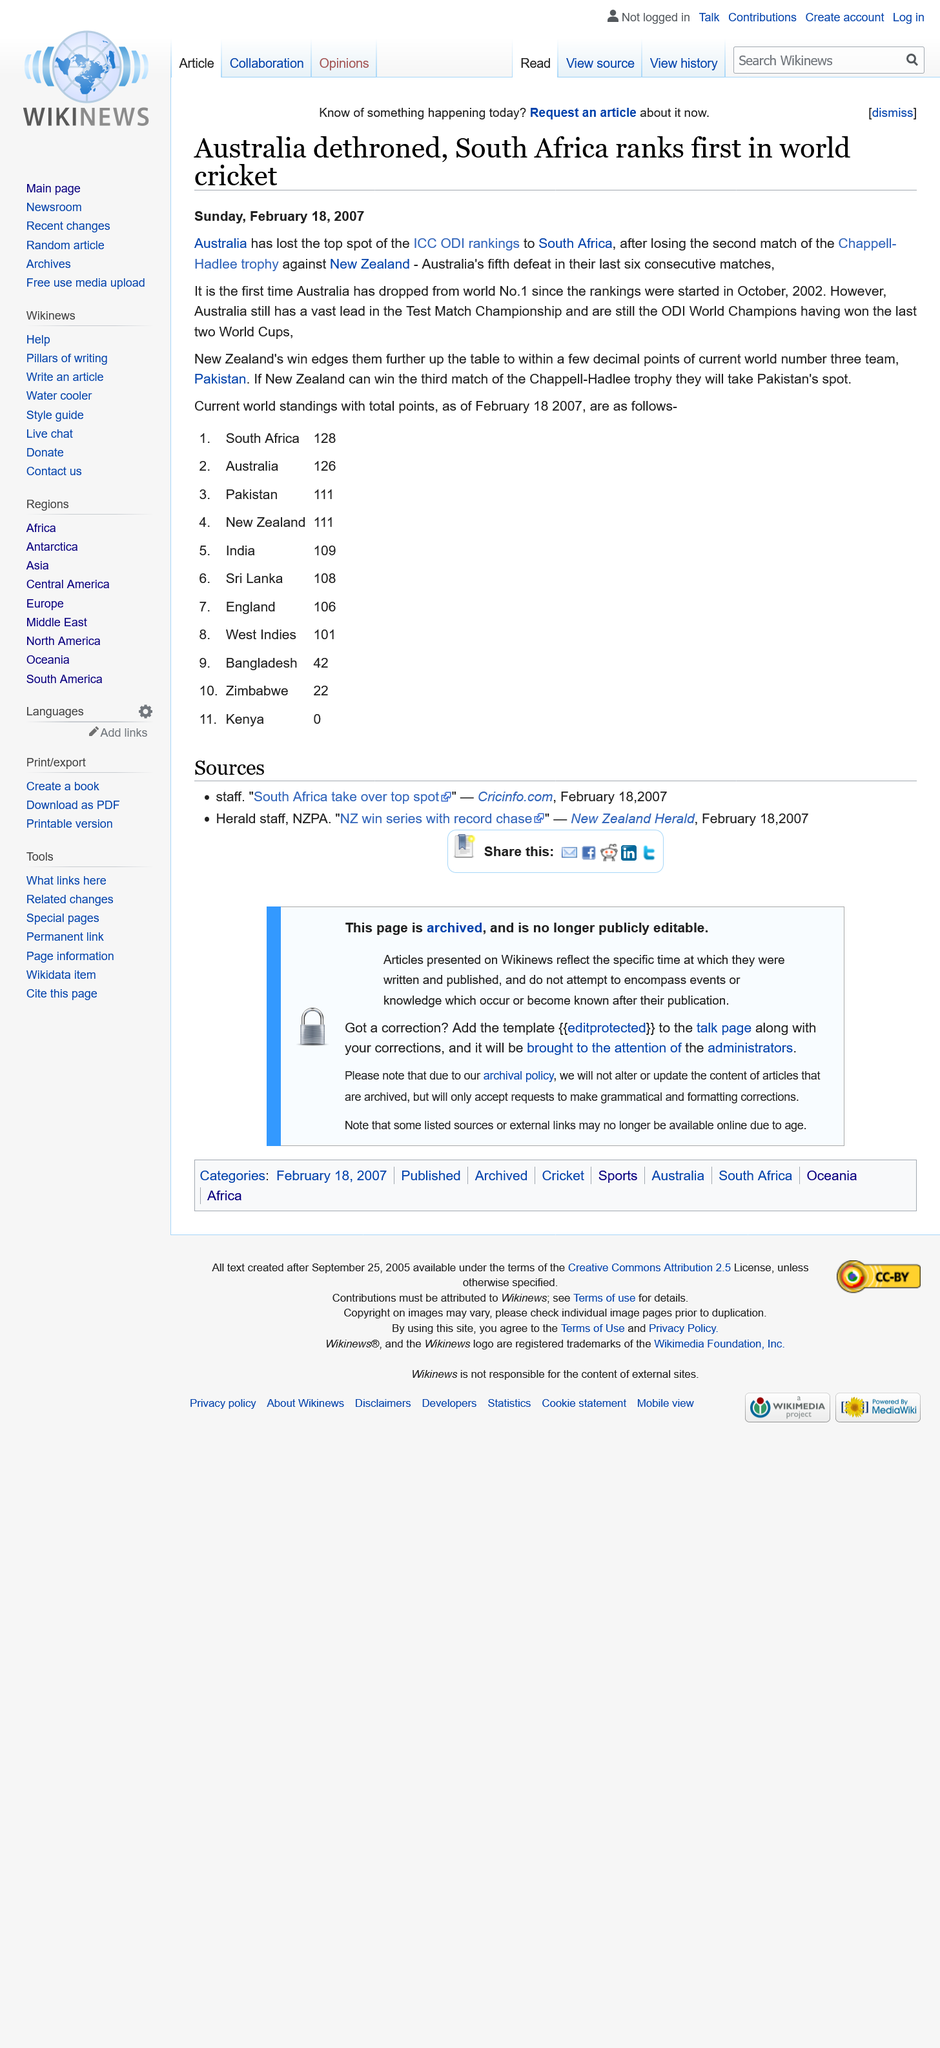Give some essential details in this illustration. On Sunday, February 18, 2007, the article on Australia being dethroned was published. Australia is the current ODI World Champions, having won the tournament in 2015. Pakistan is the current world number three team, as declared by the world rankings. 